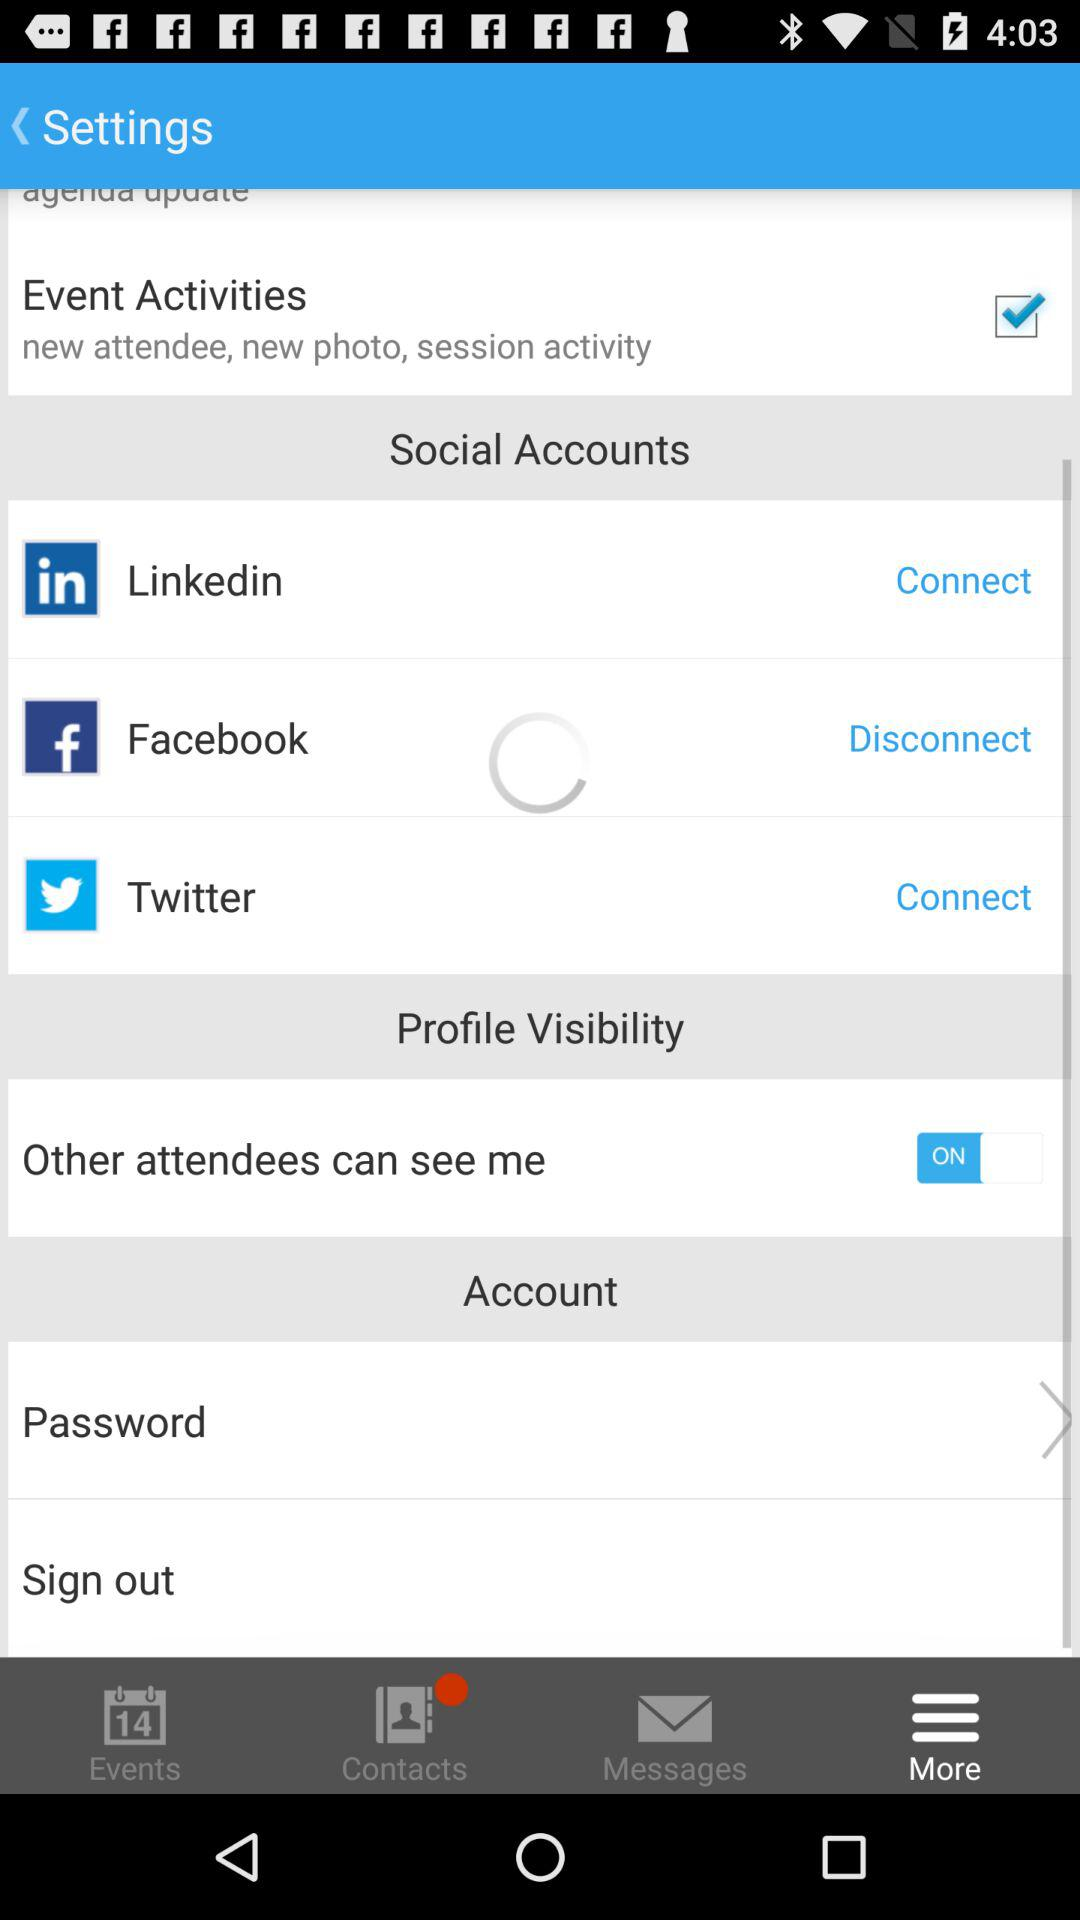What is the event date?
When the provided information is insufficient, respond with <no answer>. <no answer> 